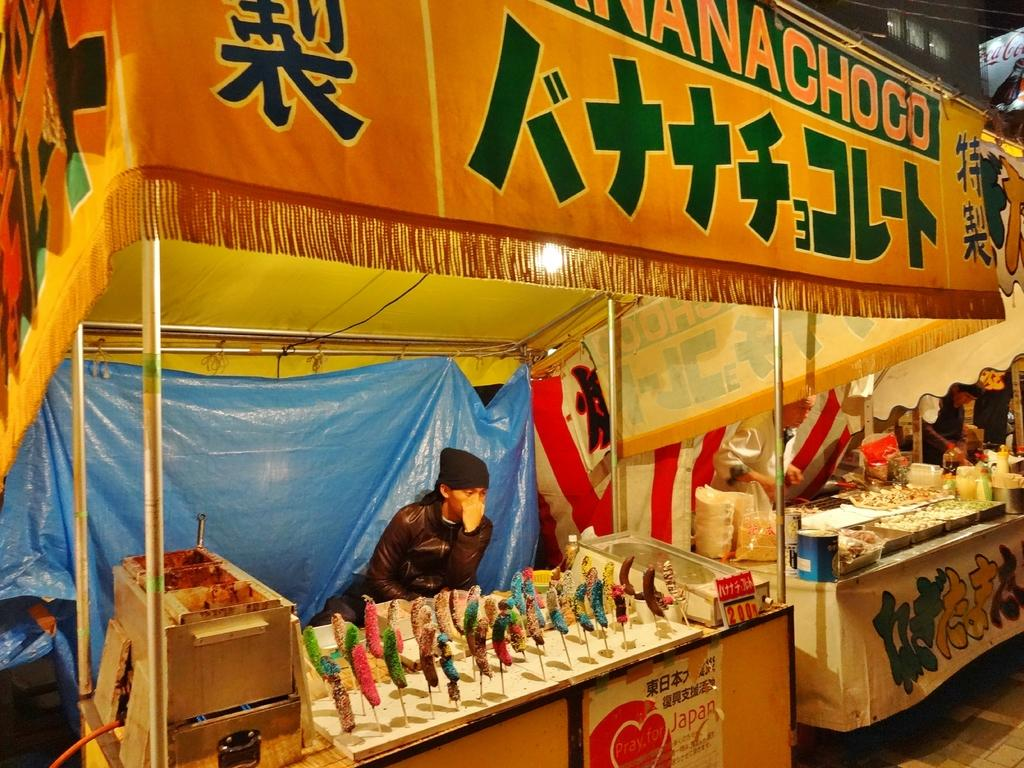What type of establishment can be seen in the image? There are food stalls in the image. What is located at the top of the image? There is a banner at the top of the image. What languages are used on the banner? The banner has text written in Japanese language and English alphabets. What type of eye can be seen in the image? There is no eye present in the image. Is there a cave visible in the image? There is no cave present in the image. 